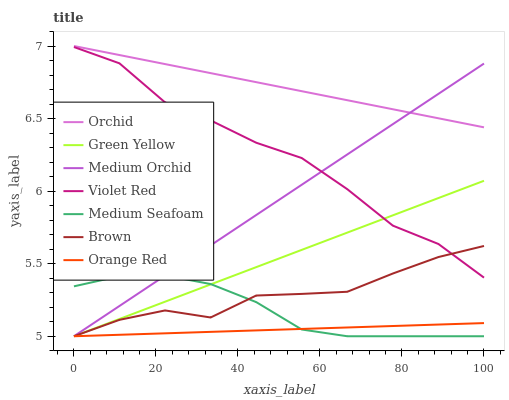Does Orange Red have the minimum area under the curve?
Answer yes or no. Yes. Does Orchid have the maximum area under the curve?
Answer yes or no. Yes. Does Violet Red have the minimum area under the curve?
Answer yes or no. No. Does Violet Red have the maximum area under the curve?
Answer yes or no. No. Is Medium Orchid the smoothest?
Answer yes or no. Yes. Is Violet Red the roughest?
Answer yes or no. Yes. Is Violet Red the smoothest?
Answer yes or no. No. Is Medium Orchid the roughest?
Answer yes or no. No. Does Violet Red have the lowest value?
Answer yes or no. No. Does Orchid have the highest value?
Answer yes or no. Yes. Does Violet Red have the highest value?
Answer yes or no. No. Is Brown less than Orchid?
Answer yes or no. Yes. Is Orchid greater than Violet Red?
Answer yes or no. Yes. Does Medium Seafoam intersect Orange Red?
Answer yes or no. Yes. Is Medium Seafoam less than Orange Red?
Answer yes or no. No. Is Medium Seafoam greater than Orange Red?
Answer yes or no. No. Does Brown intersect Orchid?
Answer yes or no. No. 